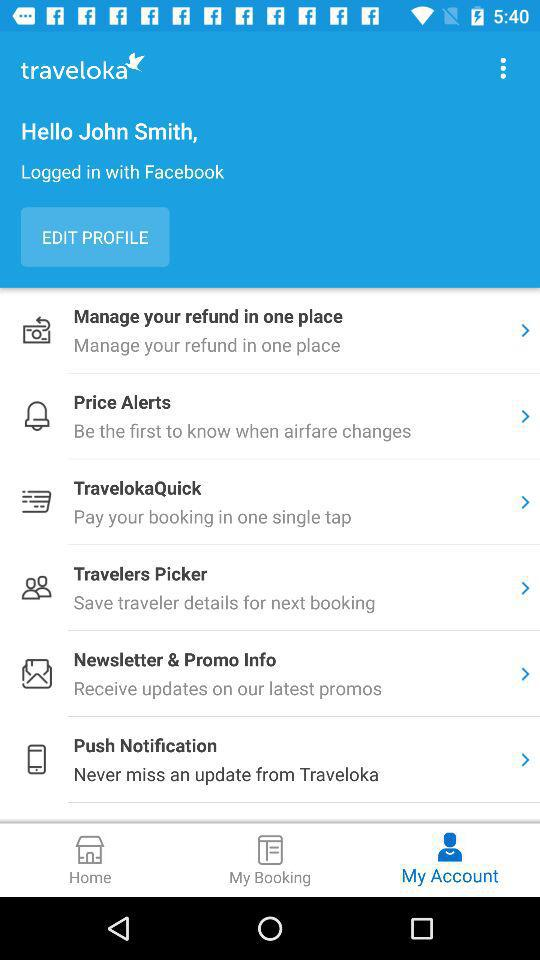How can we login? You can login with "Facebook". 